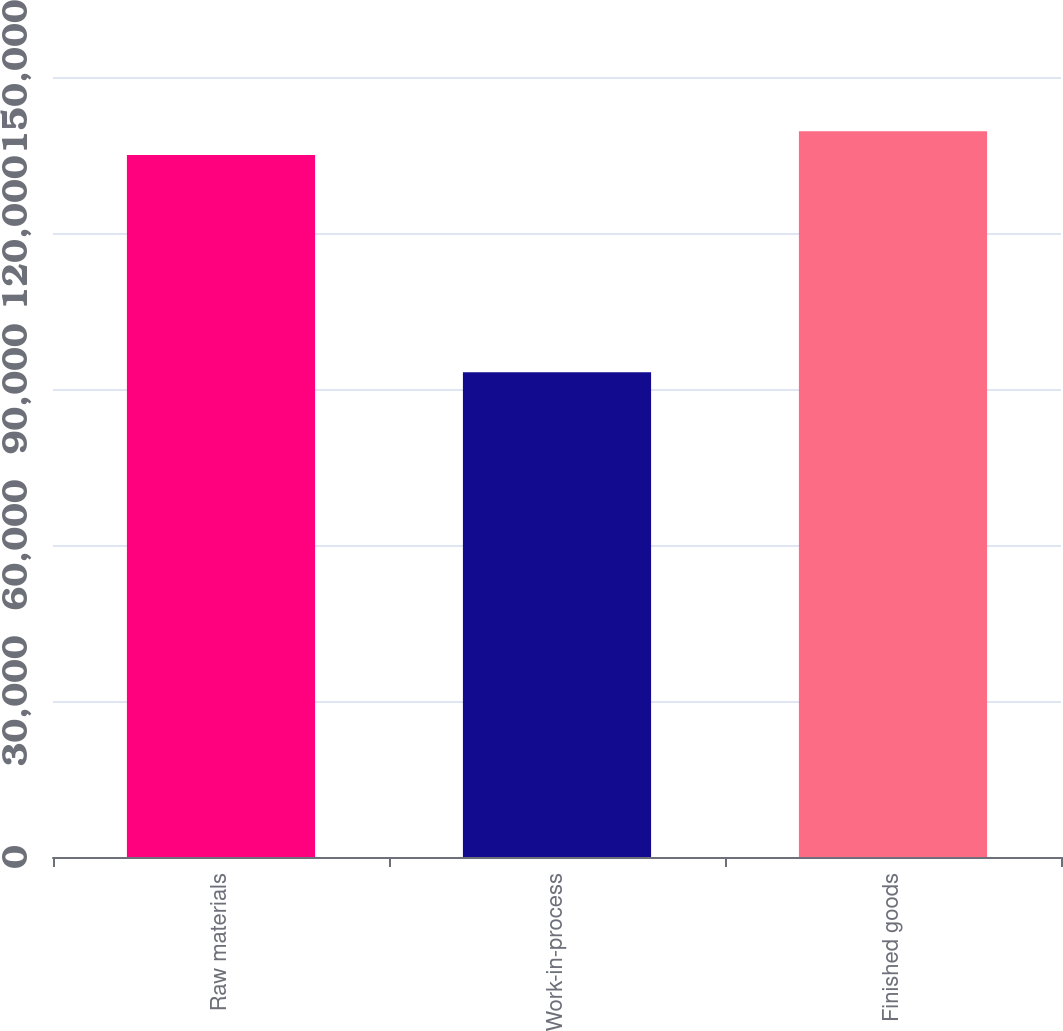Convert chart. <chart><loc_0><loc_0><loc_500><loc_500><bar_chart><fcel>Raw materials<fcel>Work-in-process<fcel>Finished goods<nl><fcel>134983<fcel>93218<fcel>139560<nl></chart> 